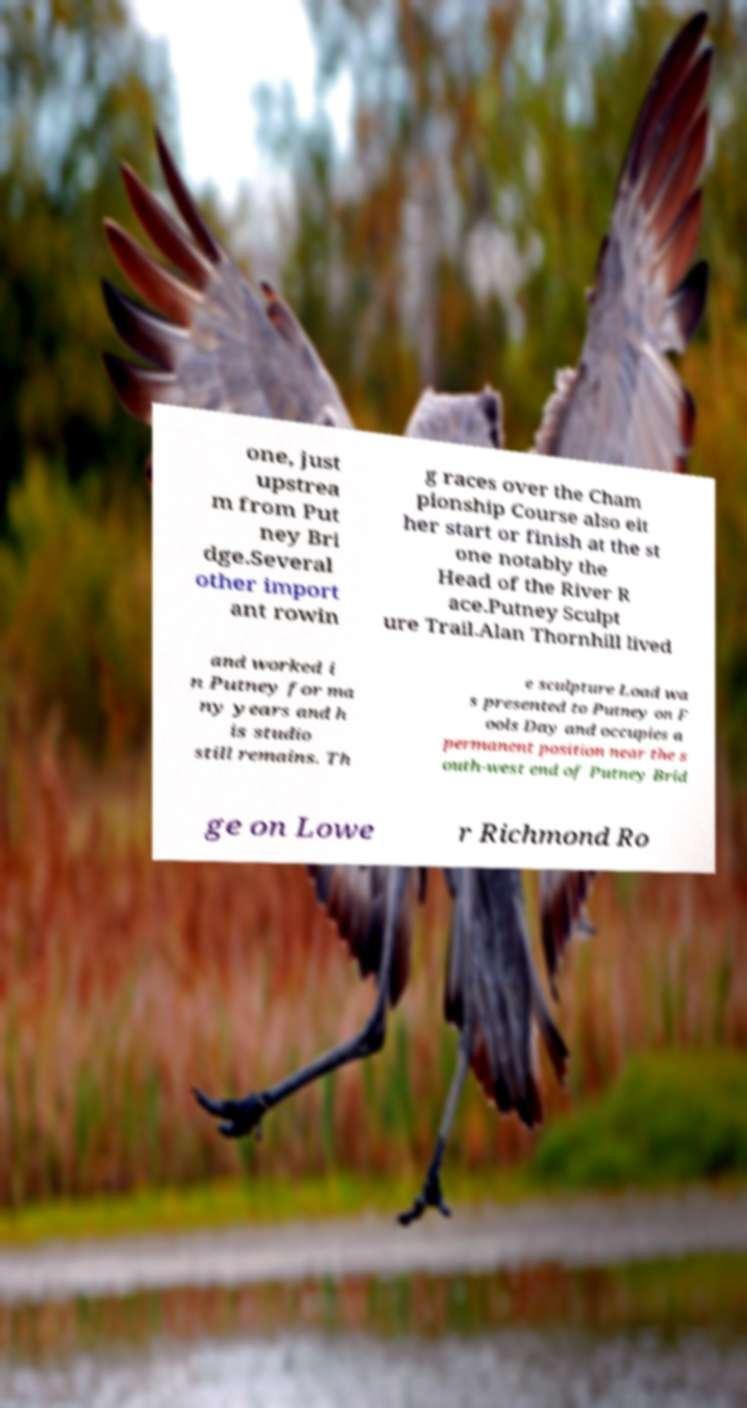Can you read and provide the text displayed in the image?This photo seems to have some interesting text. Can you extract and type it out for me? one, just upstrea m from Put ney Bri dge.Several other import ant rowin g races over the Cham pionship Course also eit her start or finish at the st one notably the Head of the River R ace.Putney Sculpt ure Trail.Alan Thornhill lived and worked i n Putney for ma ny years and h is studio still remains. Th e sculpture Load wa s presented to Putney on F ools Day and occupies a permanent position near the s outh-west end of Putney Brid ge on Lowe r Richmond Ro 